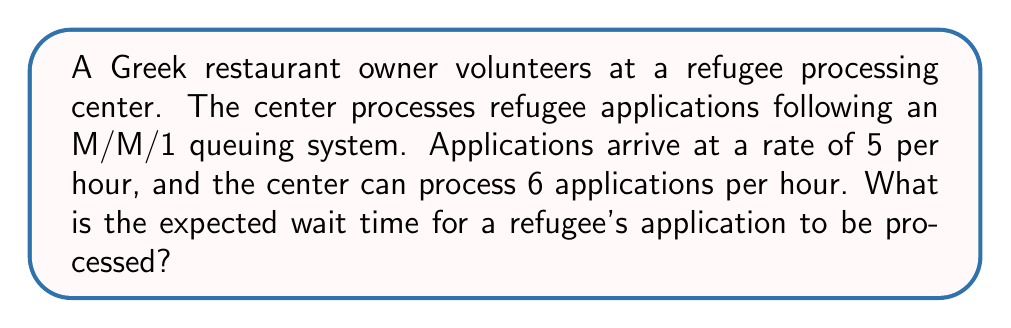What is the answer to this math problem? To solve this problem, we'll use queuing theory, specifically the M/M/1 model:

1. Define the parameters:
   $\lambda$ = arrival rate = 5 applications/hour
   $\mu$ = service rate = 6 applications/hour

2. Calculate the utilization factor $\rho$:
   $\rho = \frac{\lambda}{\mu} = \frac{5}{6} \approx 0.833$

3. The expected number of applications in the system (L) is given by:
   $L = \frac{\rho}{1-\rho} = \frac{5/6}{1-5/6} = 5$

4. Using Little's Law, we can calculate the expected time in the system (W):
   $W = \frac{L}{\lambda} = \frac{5}{5} = 1$ hour

5. The expected wait time (Wq) is the total time in the system minus the service time:
   $W_q = W - \frac{1}{\mu} = 1 - \frac{1}{6} = \frac{5}{6}$ hour

6. Convert to minutes:
   $\frac{5}{6} \text{ hour} \times 60 \text{ minutes/hour} = 50 \text{ minutes}$
Answer: 50 minutes 